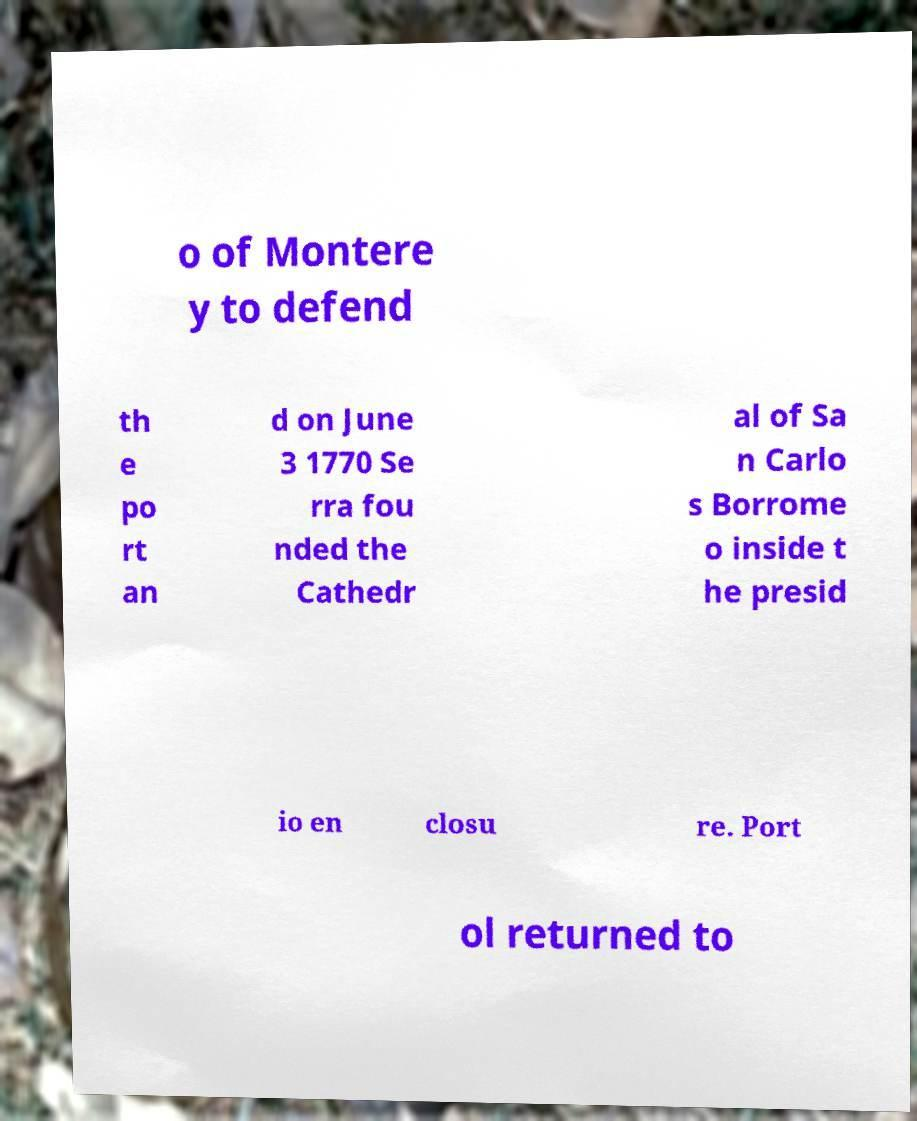Please identify and transcribe the text found in this image. o of Montere y to defend th e po rt an d on June 3 1770 Se rra fou nded the Cathedr al of Sa n Carlo s Borrome o inside t he presid io en closu re. Port ol returned to 